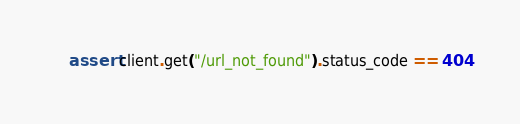<code> <loc_0><loc_0><loc_500><loc_500><_Python_>    assert client.get("/url_not_found").status_code == 404
</code> 